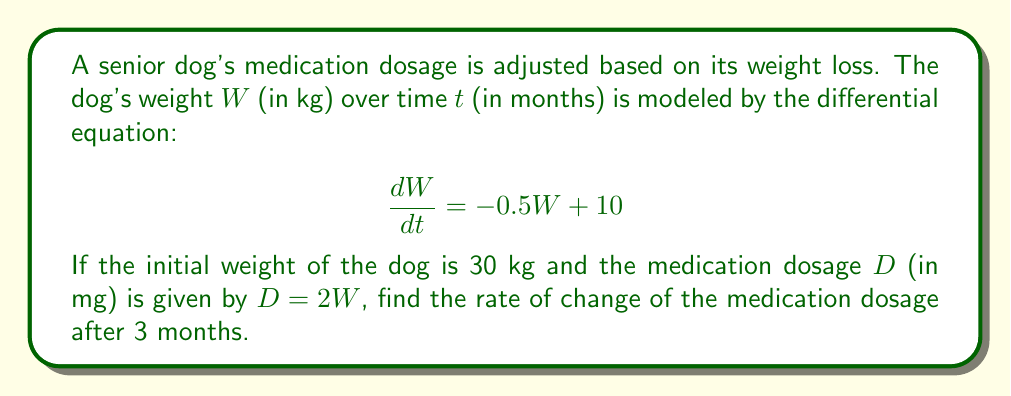Show me your answer to this math problem. 1) First, we need to solve the differential equation for $W(t)$:
   $$\frac{dW}{dt} = -0.5W + 10$$
   This is a linear first-order ODE. The general solution is:
   $$W(t) = 20 + Ce^{-0.5t}$$

2) Using the initial condition $W(0) = 30$, we can find $C$:
   $$30 = 20 + C$$
   $$C = 10$$

3) So, the particular solution for $W(t)$ is:
   $$W(t) = 20 + 10e^{-0.5t}$$

4) Now, we can express $D$ in terms of $t$:
   $$D(t) = 2W(t) = 2(20 + 10e^{-0.5t}) = 40 + 20e^{-0.5t}$$

5) To find the rate of change of $D$, we differentiate with respect to $t$:
   $$\frac{dD}{dt} = \frac{d}{dt}(40 + 20e^{-0.5t}) = -10e^{-0.5t}$$

6) Finally, we evaluate this at $t = 3$:
   $$\left.\frac{dD}{dt}\right|_{t=3} = -10e^{-0.5(3)} = -10e^{-1.5} \approx -2.24$$
Answer: $-10e^{-1.5}$ mg/month 